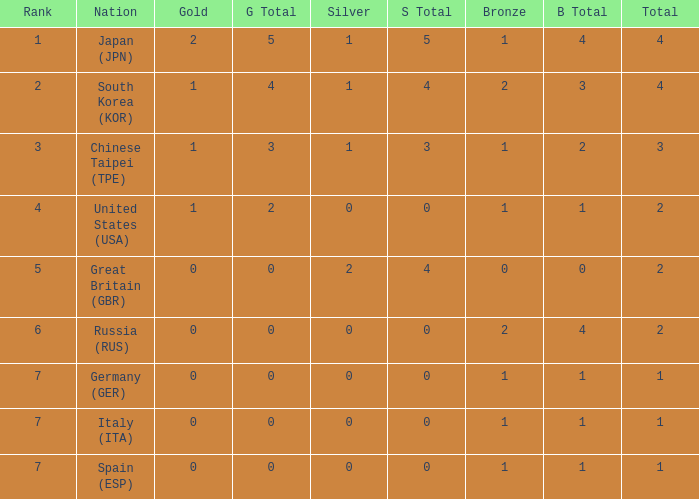Could you help me parse every detail presented in this table? {'header': ['Rank', 'Nation', 'Gold', 'G Total', 'Silver', 'S Total', 'Bronze', 'B Total', 'Total'], 'rows': [['1', 'Japan (JPN)', '2', '5', '1', '5', '1', '4', '4'], ['2', 'South Korea (KOR)', '1', '4', '1', '4', '2', '3', '4'], ['3', 'Chinese Taipei (TPE)', '1', '3', '1', '3', '1', '2', '3'], ['4', 'United States (USA)', '1', '2', '0', '0', '1', '1', '2'], ['5', 'Great Britain (GBR)', '0', '0', '2', '4', '0', '0', '2'], ['6', 'Russia (RUS)', '0', '0', '0', '0', '2', '4', '2'], ['7', 'Germany (GER)', '0', '0', '0', '0', '1', '1', '1'], ['7', 'Italy (ITA)', '0', '0', '0', '0', '1', '1', '1'], ['7', 'Spain (ESP)', '0', '0', '0', '0', '1', '1', '1']]} What is the smallest number of gold of a country of rank 6, with 2 bronzes? None. 